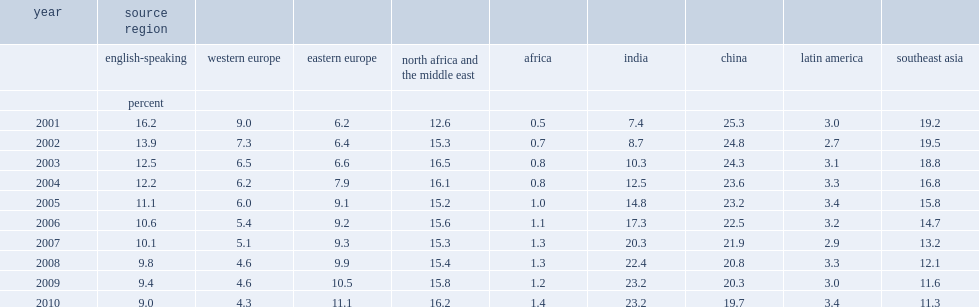What the percent of immigrants from india and the region and from china and the region together accounted for by 2010? 42.9. 